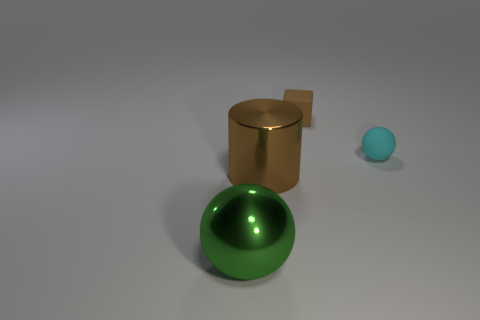Are there any objects that have the same color as the small block?
Keep it short and to the point. Yes. Is the large cylinder the same color as the small rubber block?
Offer a terse response. Yes. What shape is the tiny matte object that is the same color as the shiny cylinder?
Provide a short and direct response. Cube. What is the size of the thing that is the same color as the small block?
Your response must be concise. Large. What number of other objects are there of the same shape as the big brown thing?
Provide a short and direct response. 0. What shape is the brown thing that is behind the large thing right of the sphere in front of the cylinder?
Offer a terse response. Cube. What number of things are large red matte spheres or brown things that are to the right of the big green ball?
Give a very brief answer. 2. There is a small object in front of the tiny brown rubber block; does it have the same shape as the brown object to the left of the tiny rubber block?
Your answer should be compact. No. How many things are either brown cubes or yellow cylinders?
Your answer should be compact. 1. Are there any blue metal cylinders?
Ensure brevity in your answer.  No. 